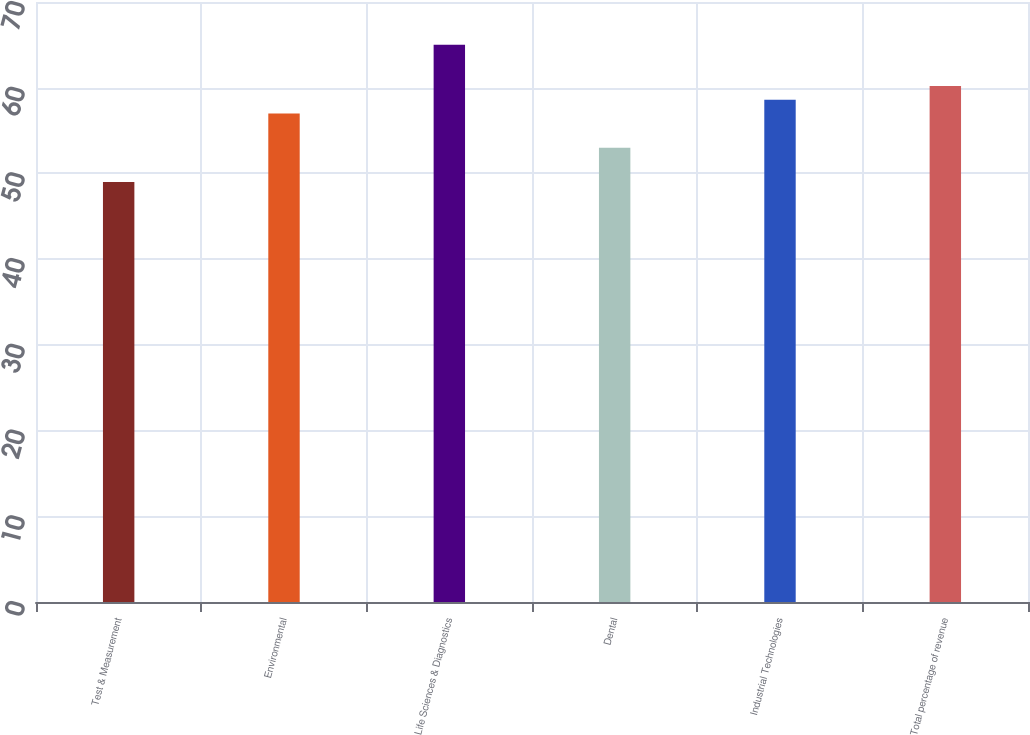Convert chart. <chart><loc_0><loc_0><loc_500><loc_500><bar_chart><fcel>Test & Measurement<fcel>Environmental<fcel>Life Sciences & Diagnostics<fcel>Dental<fcel>Industrial Technologies<fcel>Total percentage of revenue<nl><fcel>49<fcel>57<fcel>65<fcel>53<fcel>58.6<fcel>60.2<nl></chart> 